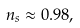<formula> <loc_0><loc_0><loc_500><loc_500>n _ { s } \approx 0 . 9 8 ,</formula> 